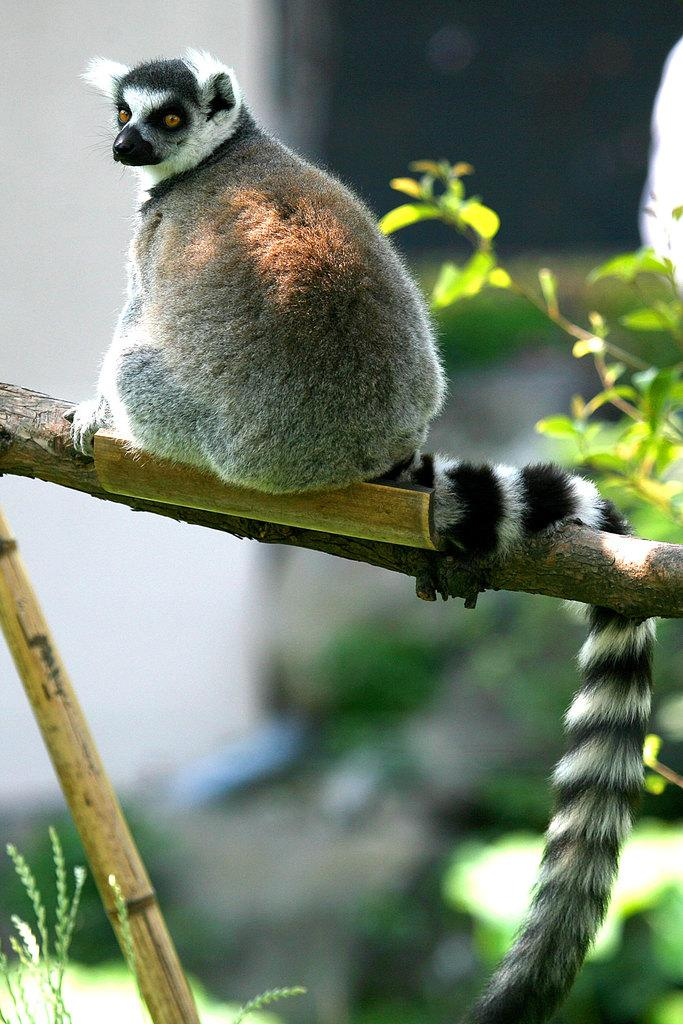What is the main subject of the image? There is an animal sitting on wood in the image. What other living organism can be seen in the image? There is a plant in the image. Can you describe the background of the image? The background of the image is blurred. What type of bun is being used as a toy by the animal in the image? There is no bun or toy present in the image; it features an animal sitting on wood and a plant. 